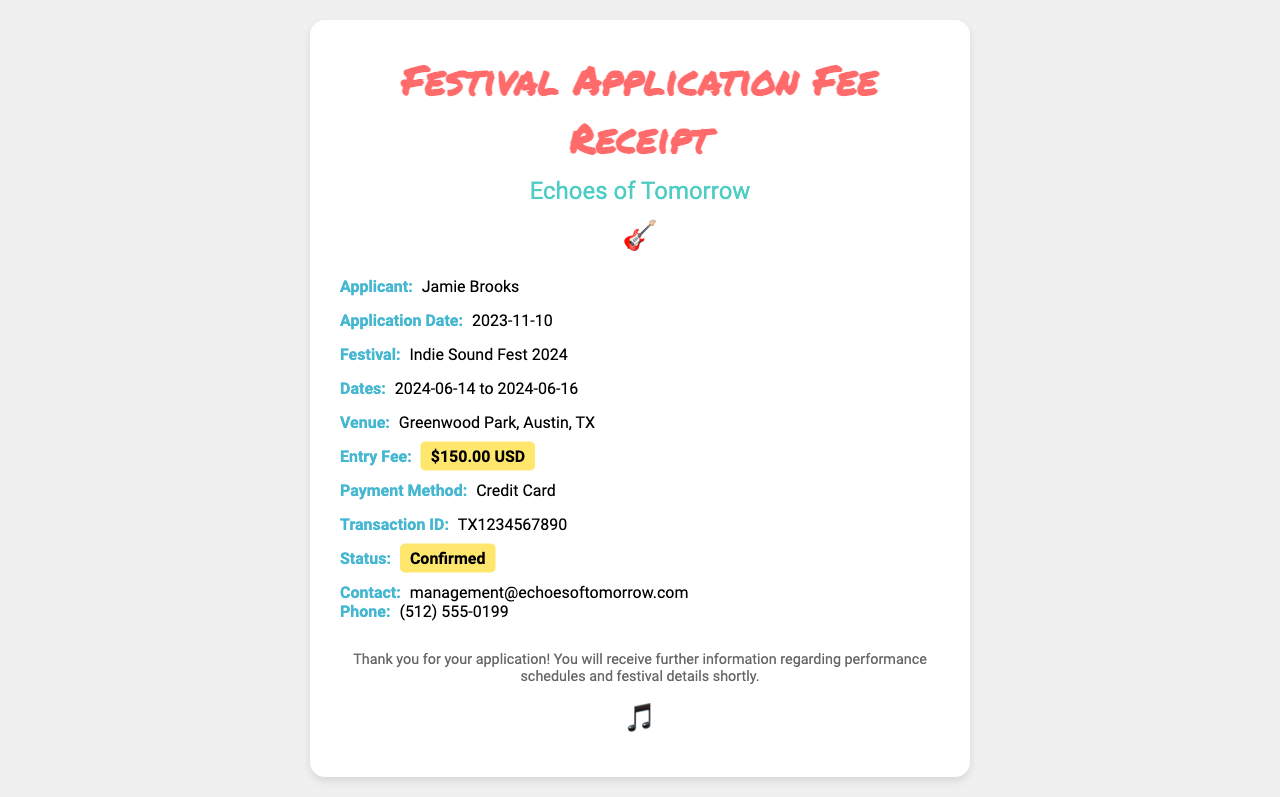What is the name of the applicant? The applicant's name is displayed in the document.
Answer: Jamie Brooks What is the application date? The application date is provided in the info group labeled "Application Date."
Answer: 2023-11-10 What is the entry fee for the festival? The entry fee is highlighted in the "Entry Fee" section of the receipt.
Answer: $150.00 USD What are the festival dates? The festival dates are specified in the "Dates" information section.
Answer: 2024-06-14 to 2024-06-16 What is the venue of the festival? The venue is mentioned in the "Venue" information section.
Answer: Greenwood Park, Austin, TX What is the transaction ID? The transaction ID is detailed in the "Transaction ID" section.
Answer: TX1234567890 What is the status of the application? The status is highlighted in the receipt, indicating the outcome of the application.
Answer: Confirmed What payment method was used? The payment method utilized for the fee is stated in the relevant section.
Answer: Credit Card What is the contact email for the band? The contact email is provided in the "Contact" details of the receipt.
Answer: management@echoesoftomorrow.com Who is the band? The band is mentioned in the header of the receipt under the band name section.
Answer: Echoes of Tomorrow 